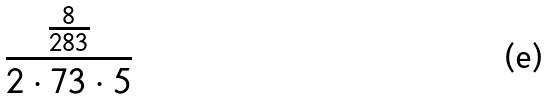<formula> <loc_0><loc_0><loc_500><loc_500>\frac { \frac { 8 } { 2 8 3 } } { 2 \cdot 7 3 \cdot 5 }</formula> 